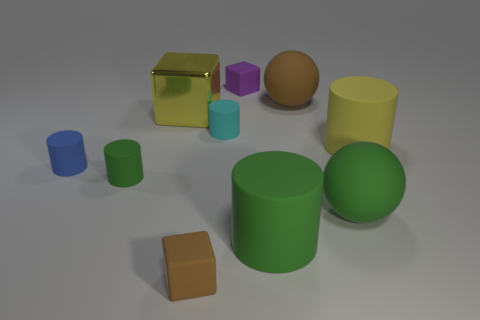Subtract all blue cylinders. How many cylinders are left? 4 Subtract all yellow cylinders. How many cylinders are left? 4 Subtract all blue cylinders. Subtract all purple cubes. How many cylinders are left? 4 Subtract all cubes. How many objects are left? 7 Add 9 yellow rubber cylinders. How many yellow rubber cylinders exist? 10 Subtract 1 brown cubes. How many objects are left? 9 Subtract all big rubber cylinders. Subtract all red metallic cylinders. How many objects are left? 8 Add 3 small green cylinders. How many small green cylinders are left? 4 